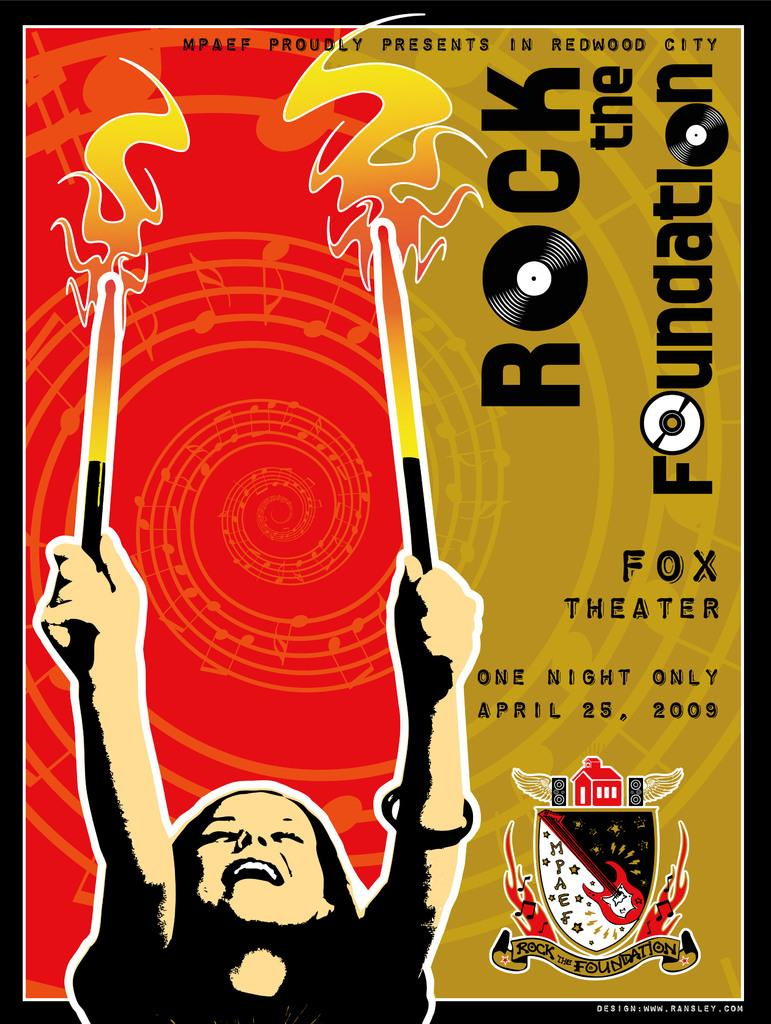<image>
Share a concise interpretation of the image provided. Rock the foundation has a date of April 25, 2009. 